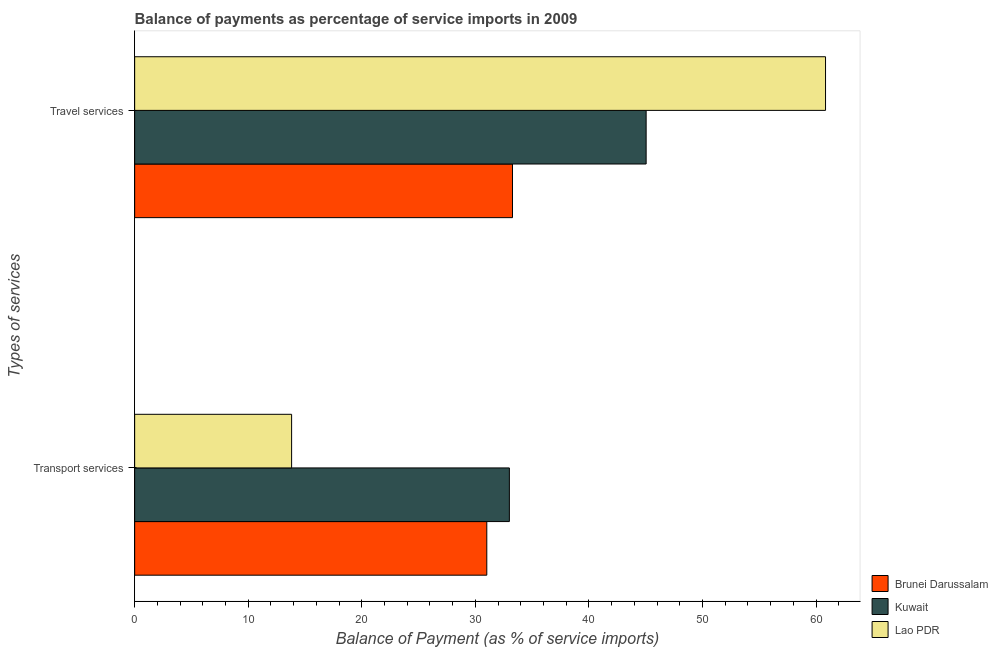How many bars are there on the 1st tick from the bottom?
Keep it short and to the point. 3. What is the label of the 1st group of bars from the top?
Give a very brief answer. Travel services. What is the balance of payments of transport services in Lao PDR?
Provide a succinct answer. 13.82. Across all countries, what is the maximum balance of payments of travel services?
Your response must be concise. 60.83. Across all countries, what is the minimum balance of payments of transport services?
Provide a succinct answer. 13.82. In which country was the balance of payments of transport services maximum?
Provide a short and direct response. Kuwait. In which country was the balance of payments of transport services minimum?
Provide a succinct answer. Lao PDR. What is the total balance of payments of travel services in the graph?
Provide a succinct answer. 139.13. What is the difference between the balance of payments of travel services in Lao PDR and that in Brunei Darussalam?
Offer a very short reply. 27.56. What is the difference between the balance of payments of travel services in Lao PDR and the balance of payments of transport services in Brunei Darussalam?
Give a very brief answer. 29.82. What is the average balance of payments of travel services per country?
Ensure brevity in your answer.  46.38. What is the difference between the balance of payments of travel services and balance of payments of transport services in Kuwait?
Your answer should be very brief. 12.04. In how many countries, is the balance of payments of transport services greater than 26 %?
Offer a terse response. 2. What is the ratio of the balance of payments of transport services in Brunei Darussalam to that in Lao PDR?
Provide a short and direct response. 2.24. Is the balance of payments of transport services in Brunei Darussalam less than that in Kuwait?
Offer a very short reply. Yes. In how many countries, is the balance of payments of travel services greater than the average balance of payments of travel services taken over all countries?
Provide a short and direct response. 1. What does the 3rd bar from the top in Travel services represents?
Your response must be concise. Brunei Darussalam. What does the 3rd bar from the bottom in Transport services represents?
Provide a short and direct response. Lao PDR. Are all the bars in the graph horizontal?
Your answer should be compact. Yes. Does the graph contain any zero values?
Provide a succinct answer. No. Does the graph contain grids?
Provide a succinct answer. No. Where does the legend appear in the graph?
Ensure brevity in your answer.  Bottom right. What is the title of the graph?
Give a very brief answer. Balance of payments as percentage of service imports in 2009. What is the label or title of the X-axis?
Your answer should be compact. Balance of Payment (as % of service imports). What is the label or title of the Y-axis?
Your answer should be compact. Types of services. What is the Balance of Payment (as % of service imports) in Brunei Darussalam in Transport services?
Make the answer very short. 31. What is the Balance of Payment (as % of service imports) of Kuwait in Transport services?
Provide a succinct answer. 32.99. What is the Balance of Payment (as % of service imports) of Lao PDR in Transport services?
Make the answer very short. 13.82. What is the Balance of Payment (as % of service imports) in Brunei Darussalam in Travel services?
Give a very brief answer. 33.27. What is the Balance of Payment (as % of service imports) of Kuwait in Travel services?
Make the answer very short. 45.03. What is the Balance of Payment (as % of service imports) in Lao PDR in Travel services?
Provide a succinct answer. 60.83. Across all Types of services, what is the maximum Balance of Payment (as % of service imports) in Brunei Darussalam?
Your answer should be very brief. 33.27. Across all Types of services, what is the maximum Balance of Payment (as % of service imports) in Kuwait?
Provide a short and direct response. 45.03. Across all Types of services, what is the maximum Balance of Payment (as % of service imports) of Lao PDR?
Make the answer very short. 60.83. Across all Types of services, what is the minimum Balance of Payment (as % of service imports) of Brunei Darussalam?
Your response must be concise. 31. Across all Types of services, what is the minimum Balance of Payment (as % of service imports) of Kuwait?
Offer a very short reply. 32.99. Across all Types of services, what is the minimum Balance of Payment (as % of service imports) in Lao PDR?
Give a very brief answer. 13.82. What is the total Balance of Payment (as % of service imports) in Brunei Darussalam in the graph?
Keep it short and to the point. 64.27. What is the total Balance of Payment (as % of service imports) in Kuwait in the graph?
Provide a short and direct response. 78.03. What is the total Balance of Payment (as % of service imports) in Lao PDR in the graph?
Your answer should be compact. 74.65. What is the difference between the Balance of Payment (as % of service imports) in Brunei Darussalam in Transport services and that in Travel services?
Offer a very short reply. -2.26. What is the difference between the Balance of Payment (as % of service imports) in Kuwait in Transport services and that in Travel services?
Make the answer very short. -12.04. What is the difference between the Balance of Payment (as % of service imports) in Lao PDR in Transport services and that in Travel services?
Give a very brief answer. -47.01. What is the difference between the Balance of Payment (as % of service imports) of Brunei Darussalam in Transport services and the Balance of Payment (as % of service imports) of Kuwait in Travel services?
Your answer should be very brief. -14.03. What is the difference between the Balance of Payment (as % of service imports) in Brunei Darussalam in Transport services and the Balance of Payment (as % of service imports) in Lao PDR in Travel services?
Provide a succinct answer. -29.82. What is the difference between the Balance of Payment (as % of service imports) of Kuwait in Transport services and the Balance of Payment (as % of service imports) of Lao PDR in Travel services?
Make the answer very short. -27.84. What is the average Balance of Payment (as % of service imports) in Brunei Darussalam per Types of services?
Give a very brief answer. 32.14. What is the average Balance of Payment (as % of service imports) of Kuwait per Types of services?
Your answer should be compact. 39.01. What is the average Balance of Payment (as % of service imports) in Lao PDR per Types of services?
Your answer should be very brief. 37.32. What is the difference between the Balance of Payment (as % of service imports) in Brunei Darussalam and Balance of Payment (as % of service imports) in Kuwait in Transport services?
Your response must be concise. -1.99. What is the difference between the Balance of Payment (as % of service imports) in Brunei Darussalam and Balance of Payment (as % of service imports) in Lao PDR in Transport services?
Offer a terse response. 17.18. What is the difference between the Balance of Payment (as % of service imports) in Kuwait and Balance of Payment (as % of service imports) in Lao PDR in Transport services?
Offer a very short reply. 19.17. What is the difference between the Balance of Payment (as % of service imports) in Brunei Darussalam and Balance of Payment (as % of service imports) in Kuwait in Travel services?
Offer a terse response. -11.77. What is the difference between the Balance of Payment (as % of service imports) in Brunei Darussalam and Balance of Payment (as % of service imports) in Lao PDR in Travel services?
Make the answer very short. -27.56. What is the difference between the Balance of Payment (as % of service imports) in Kuwait and Balance of Payment (as % of service imports) in Lao PDR in Travel services?
Provide a short and direct response. -15.79. What is the ratio of the Balance of Payment (as % of service imports) in Brunei Darussalam in Transport services to that in Travel services?
Your answer should be compact. 0.93. What is the ratio of the Balance of Payment (as % of service imports) in Kuwait in Transport services to that in Travel services?
Provide a succinct answer. 0.73. What is the ratio of the Balance of Payment (as % of service imports) of Lao PDR in Transport services to that in Travel services?
Make the answer very short. 0.23. What is the difference between the highest and the second highest Balance of Payment (as % of service imports) in Brunei Darussalam?
Offer a very short reply. 2.26. What is the difference between the highest and the second highest Balance of Payment (as % of service imports) in Kuwait?
Make the answer very short. 12.04. What is the difference between the highest and the second highest Balance of Payment (as % of service imports) in Lao PDR?
Your answer should be very brief. 47.01. What is the difference between the highest and the lowest Balance of Payment (as % of service imports) in Brunei Darussalam?
Provide a short and direct response. 2.26. What is the difference between the highest and the lowest Balance of Payment (as % of service imports) of Kuwait?
Offer a very short reply. 12.04. What is the difference between the highest and the lowest Balance of Payment (as % of service imports) of Lao PDR?
Make the answer very short. 47.01. 